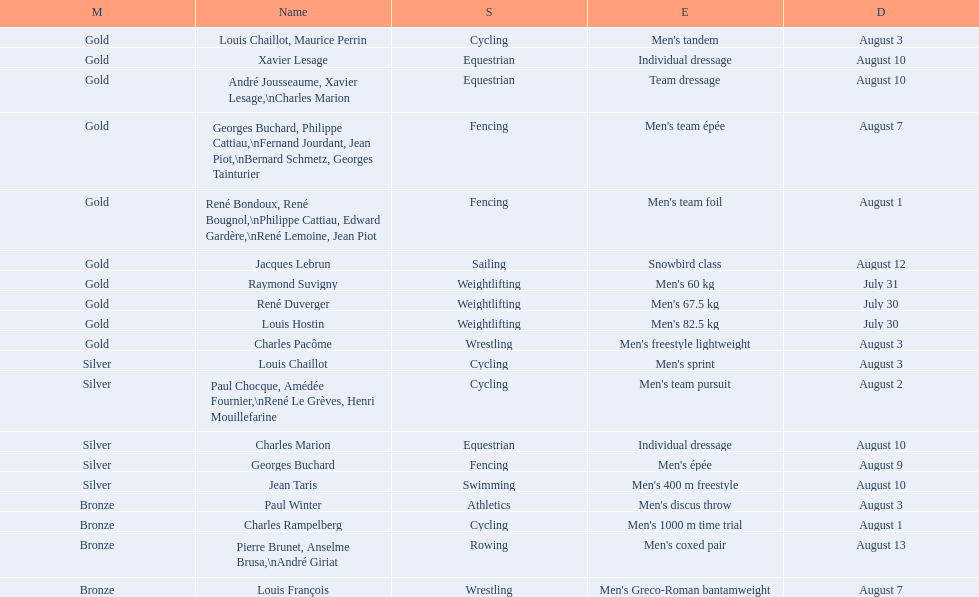What sport did louis challiot win the same medal as paul chocque in? Cycling. 